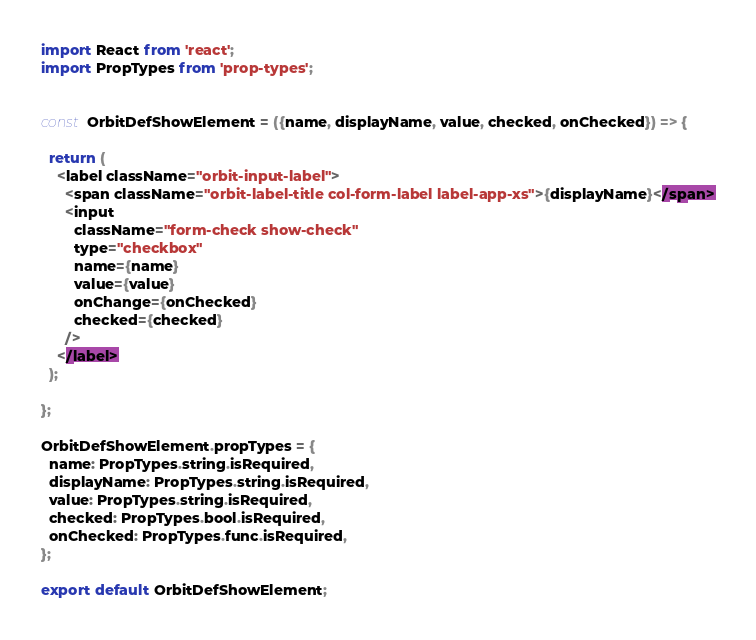Convert code to text. <code><loc_0><loc_0><loc_500><loc_500><_JavaScript_>import React from 'react';
import PropTypes from 'prop-types';


const OrbitDefShowElement = ({name, displayName, value, checked, onChecked}) => {

  return (
    <label className="orbit-input-label">
      <span className="orbit-label-title col-form-label label-app-xs">{displayName}</span>
      <input
        className="form-check show-check"
        type="checkbox"
        name={name}
        value={value}
        onChange={onChecked}
        checked={checked}
      />
    </label>
  );

};

OrbitDefShowElement.propTypes = {
  name: PropTypes.string.isRequired,
  displayName: PropTypes.string.isRequired,
  value: PropTypes.string.isRequired,
  checked: PropTypes.bool.isRequired,
  onChecked: PropTypes.func.isRequired,
};

export default OrbitDefShowElement;
</code> 